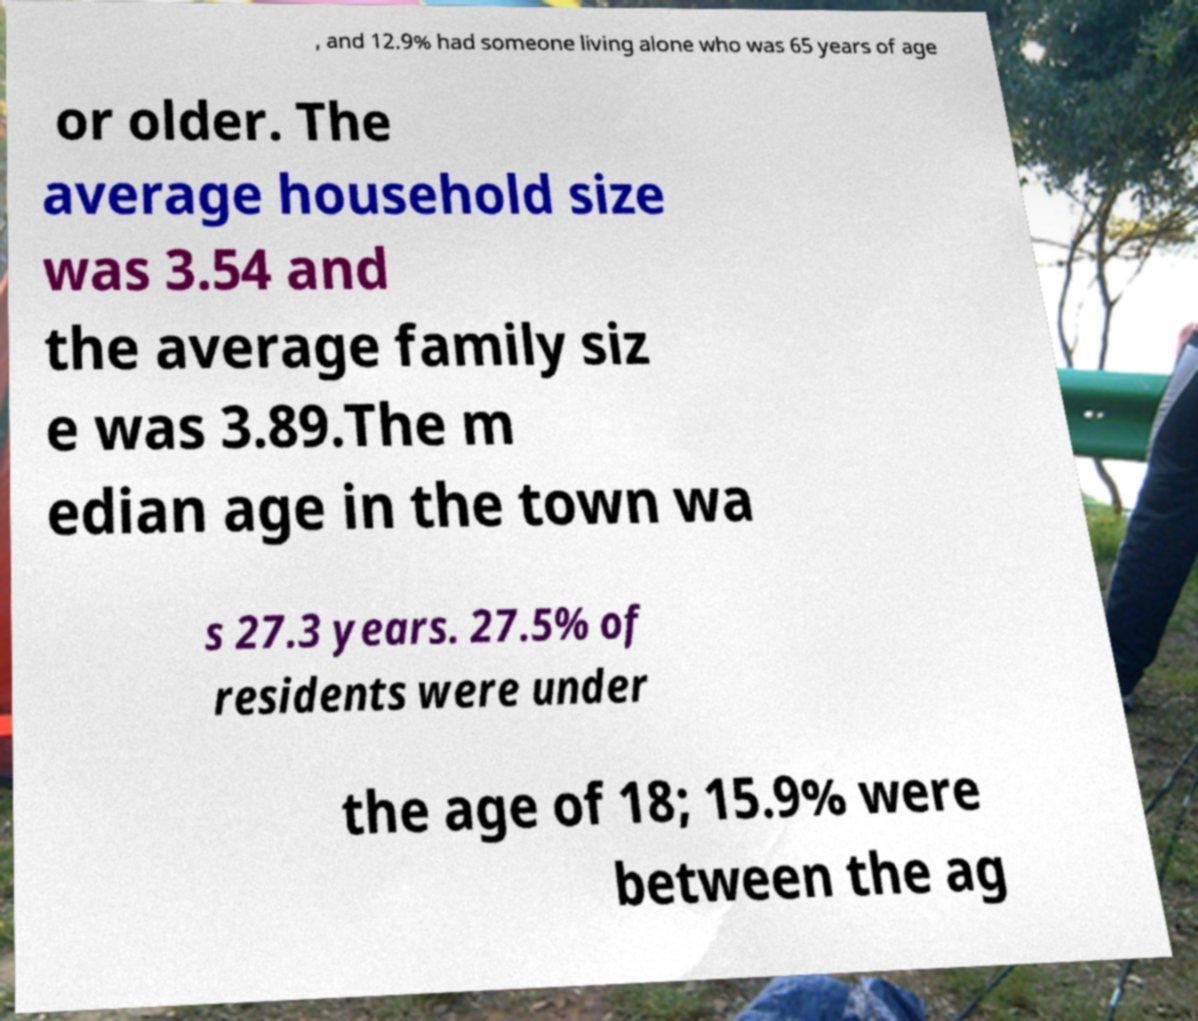Could you assist in decoding the text presented in this image and type it out clearly? , and 12.9% had someone living alone who was 65 years of age or older. The average household size was 3.54 and the average family siz e was 3.89.The m edian age in the town wa s 27.3 years. 27.5% of residents were under the age of 18; 15.9% were between the ag 